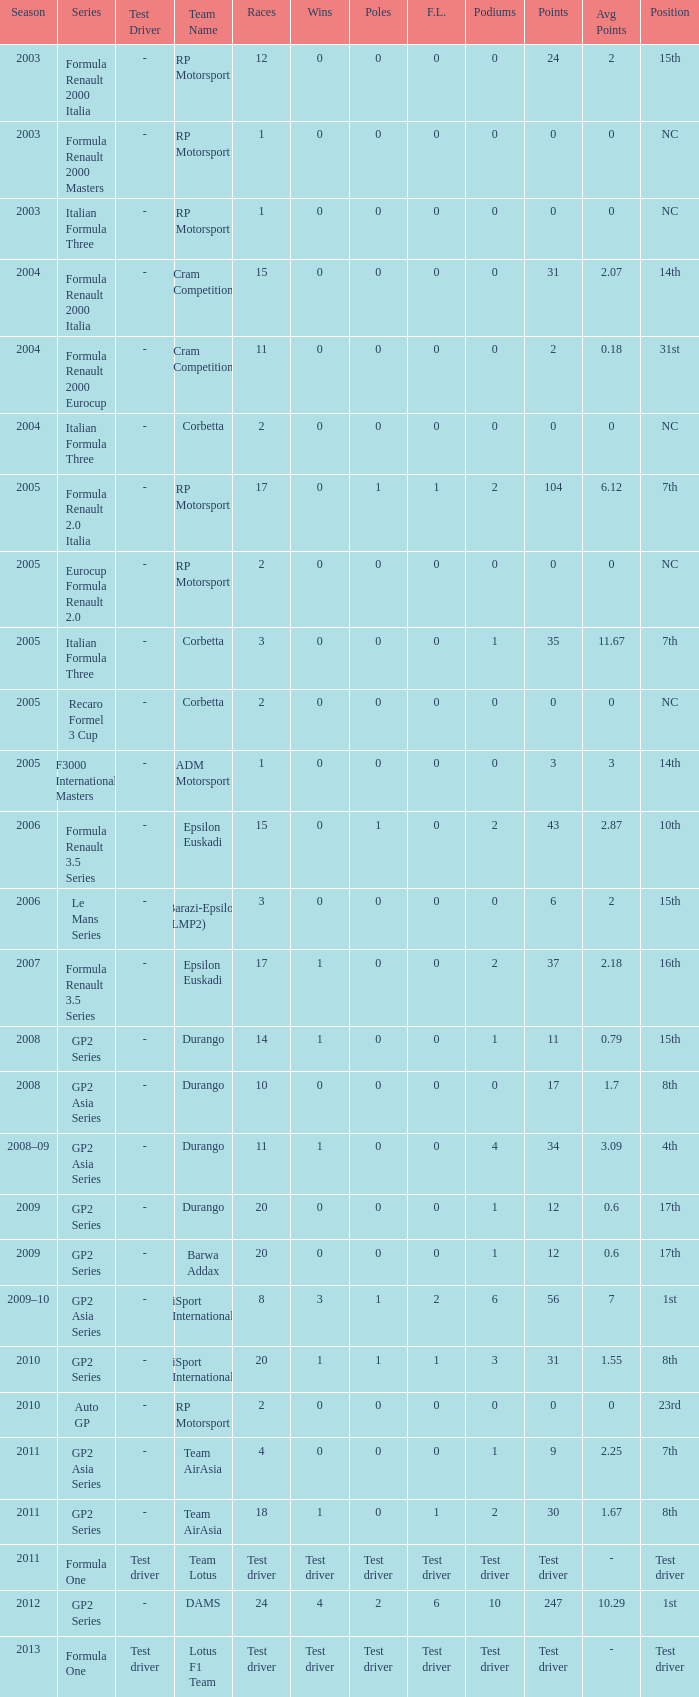What races have gp2 series, 0 F.L. and a 17th position? 20, 20. 